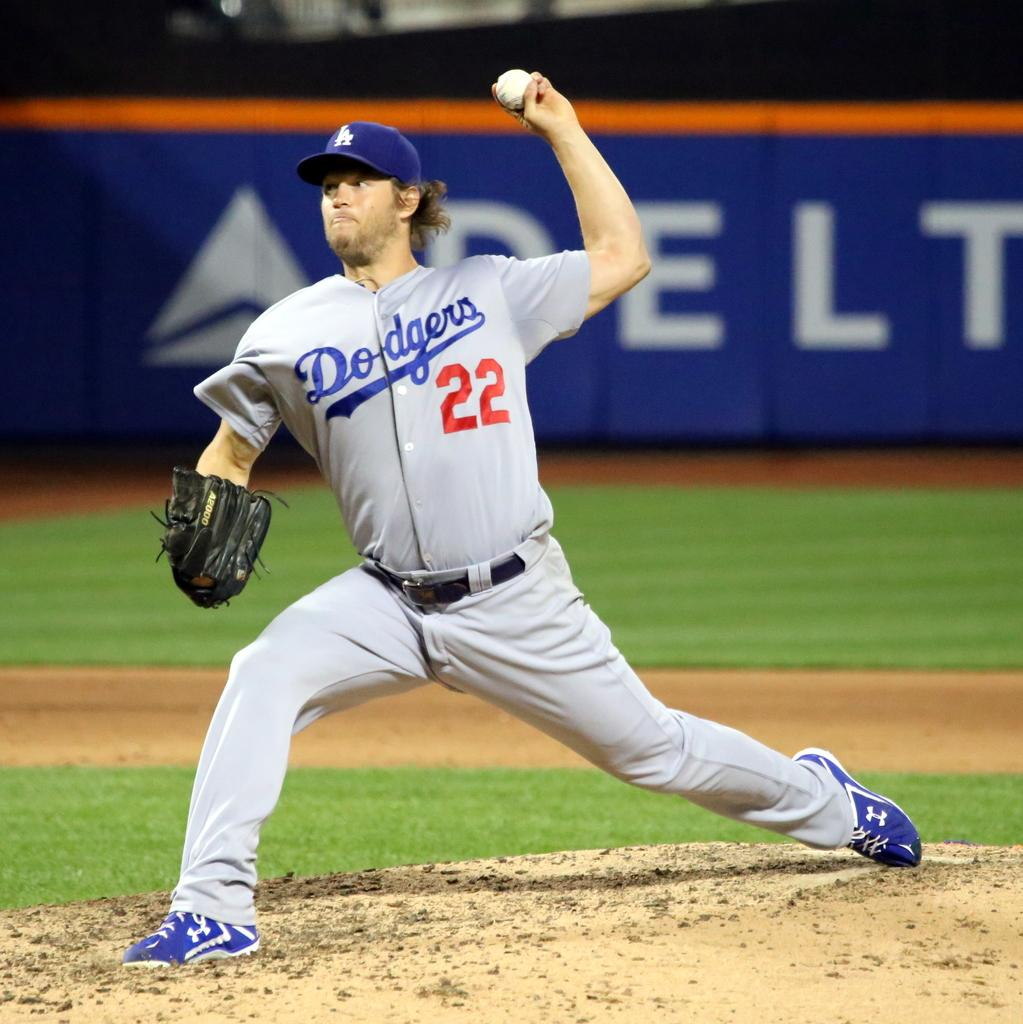<image>
Create a compact narrative representing the image presented. a baseball player wearing a 'dodgers 22' uniform 